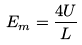<formula> <loc_0><loc_0><loc_500><loc_500>E _ { m } = \frac { 4 U } { L }</formula> 